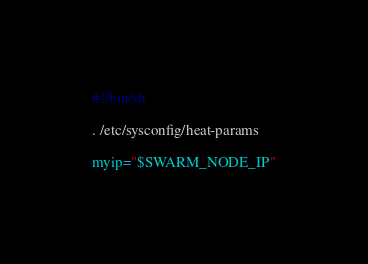<code> <loc_0><loc_0><loc_500><loc_500><_Bash_>#!/bin/sh

. /etc/sysconfig/heat-params

myip="$SWARM_NODE_IP"
</code> 